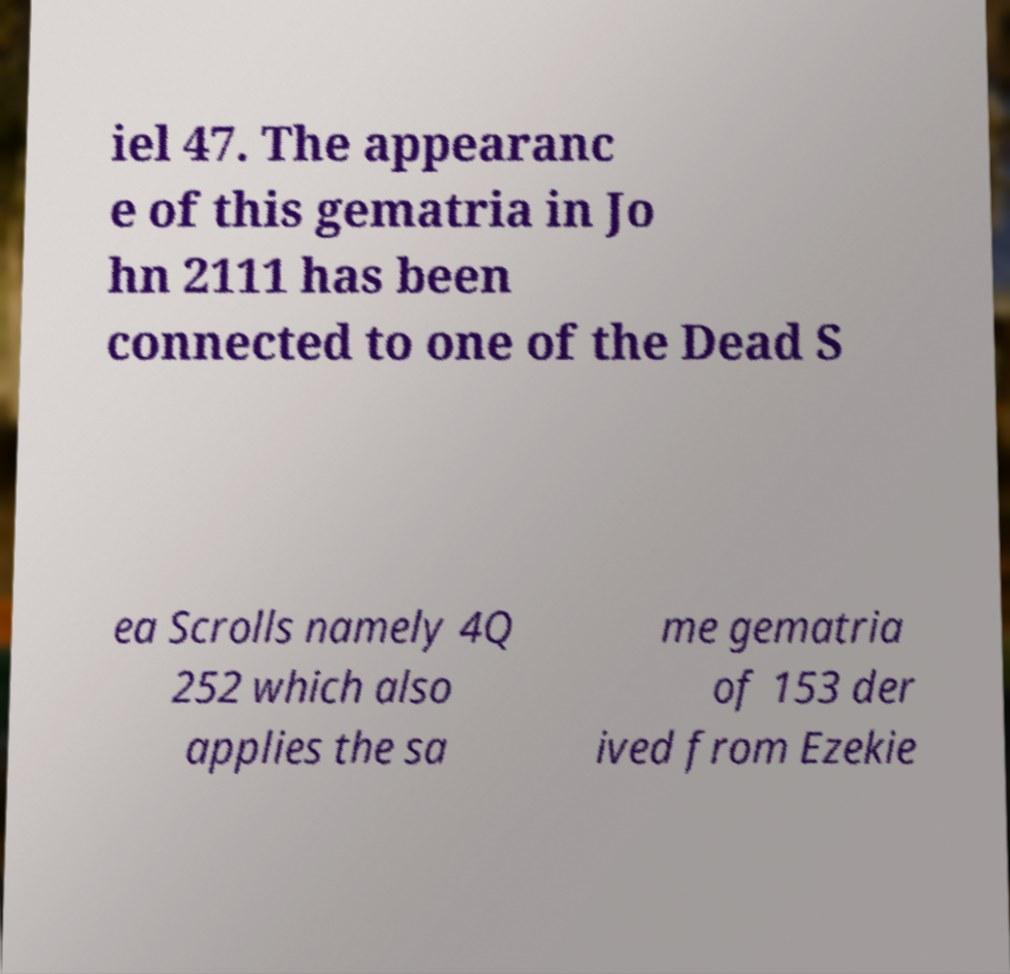Could you assist in decoding the text presented in this image and type it out clearly? iel 47. The appearanc e of this gematria in Jo hn 2111 has been connected to one of the Dead S ea Scrolls namely 4Q 252 which also applies the sa me gematria of 153 der ived from Ezekie 